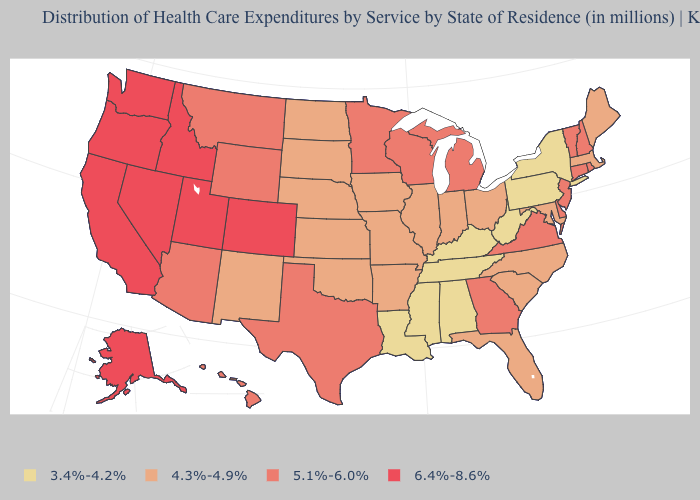Does Michigan have a higher value than Washington?
Quick response, please. No. Name the states that have a value in the range 4.3%-4.9%?
Give a very brief answer. Arkansas, Florida, Illinois, Indiana, Iowa, Kansas, Maine, Maryland, Massachusetts, Missouri, Nebraska, New Mexico, North Carolina, North Dakota, Ohio, Oklahoma, South Carolina, South Dakota. Does New Jersey have the same value as Wyoming?
Be succinct. Yes. Name the states that have a value in the range 3.4%-4.2%?
Write a very short answer. Alabama, Kentucky, Louisiana, Mississippi, New York, Pennsylvania, Tennessee, West Virginia. Which states have the highest value in the USA?
Give a very brief answer. Alaska, California, Colorado, Idaho, Nevada, Oregon, Utah, Washington. What is the value of Hawaii?
Write a very short answer. 5.1%-6.0%. Name the states that have a value in the range 6.4%-8.6%?
Be succinct. Alaska, California, Colorado, Idaho, Nevada, Oregon, Utah, Washington. Name the states that have a value in the range 4.3%-4.9%?
Concise answer only. Arkansas, Florida, Illinois, Indiana, Iowa, Kansas, Maine, Maryland, Massachusetts, Missouri, Nebraska, New Mexico, North Carolina, North Dakota, Ohio, Oklahoma, South Carolina, South Dakota. What is the value of Connecticut?
Quick response, please. 5.1%-6.0%. What is the value of Tennessee?
Short answer required. 3.4%-4.2%. What is the highest value in the USA?
Write a very short answer. 6.4%-8.6%. Which states have the highest value in the USA?
Be succinct. Alaska, California, Colorado, Idaho, Nevada, Oregon, Utah, Washington. Among the states that border Wyoming , does Colorado have the lowest value?
Write a very short answer. No. Name the states that have a value in the range 6.4%-8.6%?
Give a very brief answer. Alaska, California, Colorado, Idaho, Nevada, Oregon, Utah, Washington. Name the states that have a value in the range 5.1%-6.0%?
Short answer required. Arizona, Connecticut, Delaware, Georgia, Hawaii, Michigan, Minnesota, Montana, New Hampshire, New Jersey, Rhode Island, Texas, Vermont, Virginia, Wisconsin, Wyoming. 